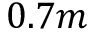<formula> <loc_0><loc_0><loc_500><loc_500>0 . 7 m</formula> 